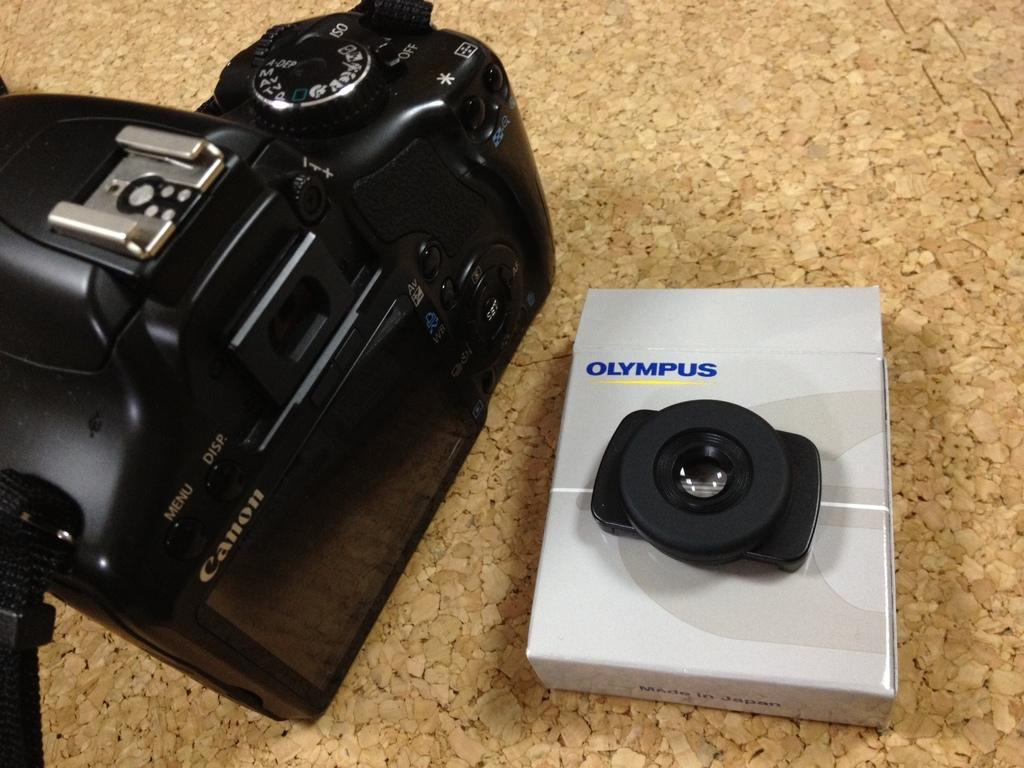What type of camera is visible in the image? There is a black color camera in the image. What other object can be seen in the image? There is a white color box in the image. How is the box colored? The box has a black color on it. Where is the writing present in the image? The writing is present in multiple places in the image. Can you tell me how many squirrels are drinking eggnog in the image? There are no squirrels or eggnog present in the image. What part of the human body is visible in the image? There is no human body present in the image. 